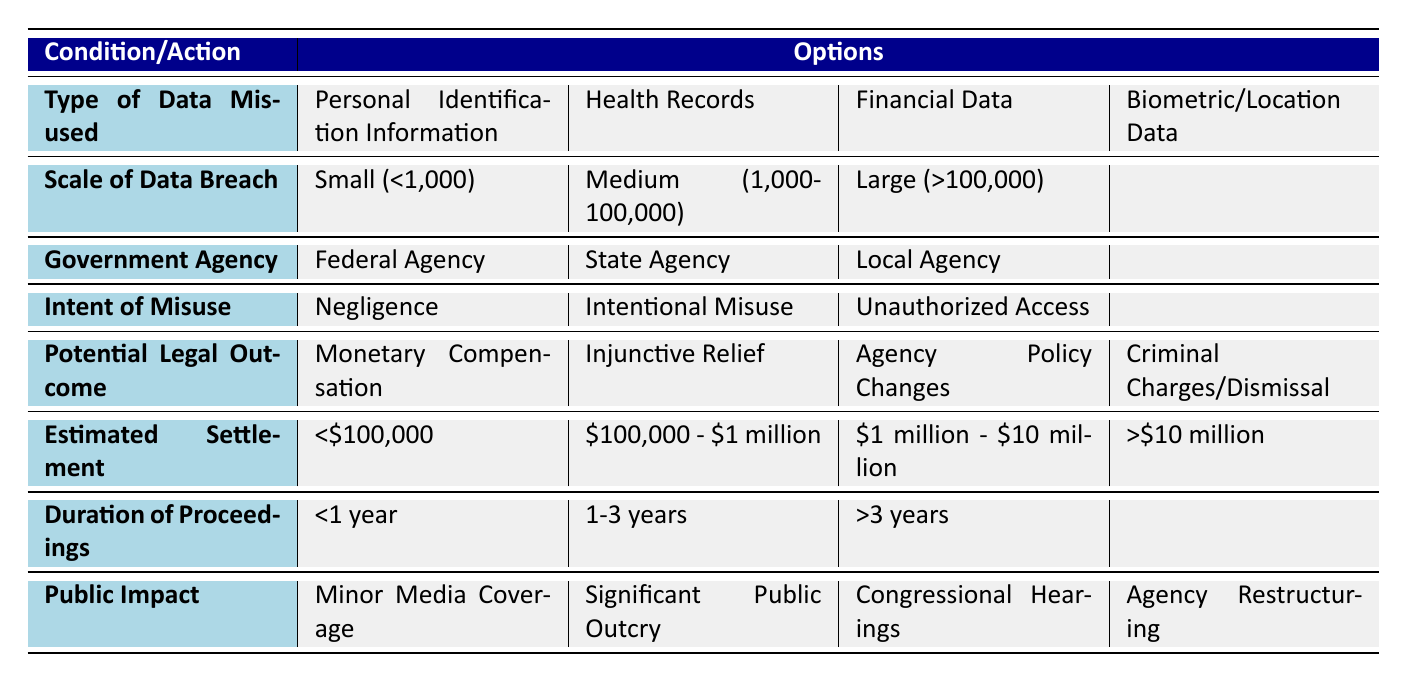What types of data are considered to be misused according to the table? The table lists five types of data that can be misused: Personal Identification Information, Health Records, Financial Data, Biometric Data, and Location Data.
Answer: Personal Identification Information, Health Records, Financial Data, Biometric Data, Location Data What is the potential legal outcome for small-scale breaches involving negligence? For small-scale breaches involving negligence, the potential legal outcome typically includes monetary compensation. This can be inferred from the structure of the table where the conditions are combined.
Answer: Monetary Compensation Is large-scale data breach more likely to lead to public impact such as Congressional Hearings? Yes, based on the table, large-scale data breaches (over 100,000 individuals affected) are more likely to have significant public impact, including Congressional Hearings.
Answer: Yes What is the estimated settlement amount for medium-scale data breaches due to intentional misuse? For medium-scale breaches (1,000 - 100,000 individuals affected) due to intentional misuse, the estimated settlement amount could be expected to fall within the range of $1 million - $10 million. This is derived from the potential legal outcomes associated with different scales and intents of misuses.
Answer: $1 million - $10 million What is the relationship between the scale of the data breach and the duration of legal proceedings? The table shows that larger scale data breaches (>100,000 individuals affected) likely lead to longer duration of legal proceedings, often more than three years. In contrast, smaller breaches may result in proceedings taking less than a year. Thus, as the scale of the breach increases, the duration of legal proceedings also tends to increase.
Answer: As scale increases, duration increases 